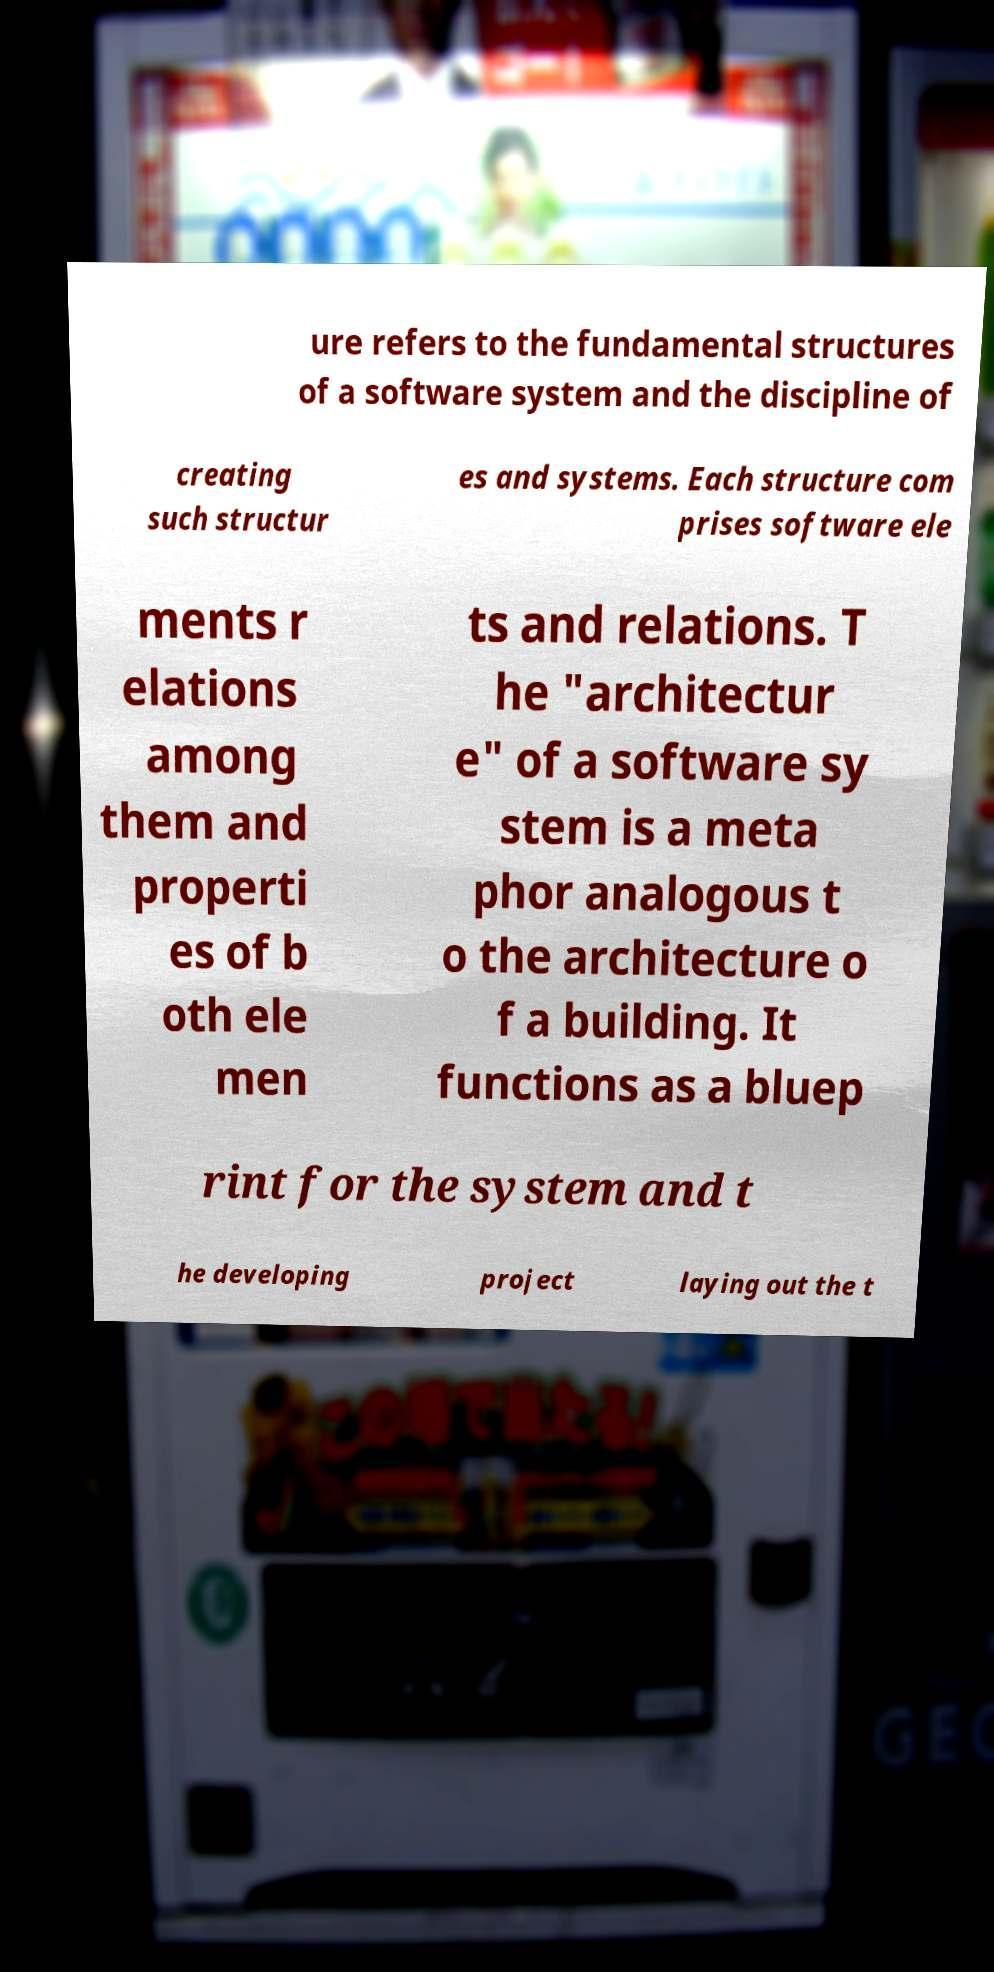What messages or text are displayed in this image? I need them in a readable, typed format. ure refers to the fundamental structures of a software system and the discipline of creating such structur es and systems. Each structure com prises software ele ments r elations among them and properti es of b oth ele men ts and relations. T he "architectur e" of a software sy stem is a meta phor analogous t o the architecture o f a building. It functions as a bluep rint for the system and t he developing project laying out the t 